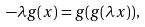Convert formula to latex. <formula><loc_0><loc_0><loc_500><loc_500>- \lambda g ( x ) = g ( g ( \lambda x ) ) ,</formula> 